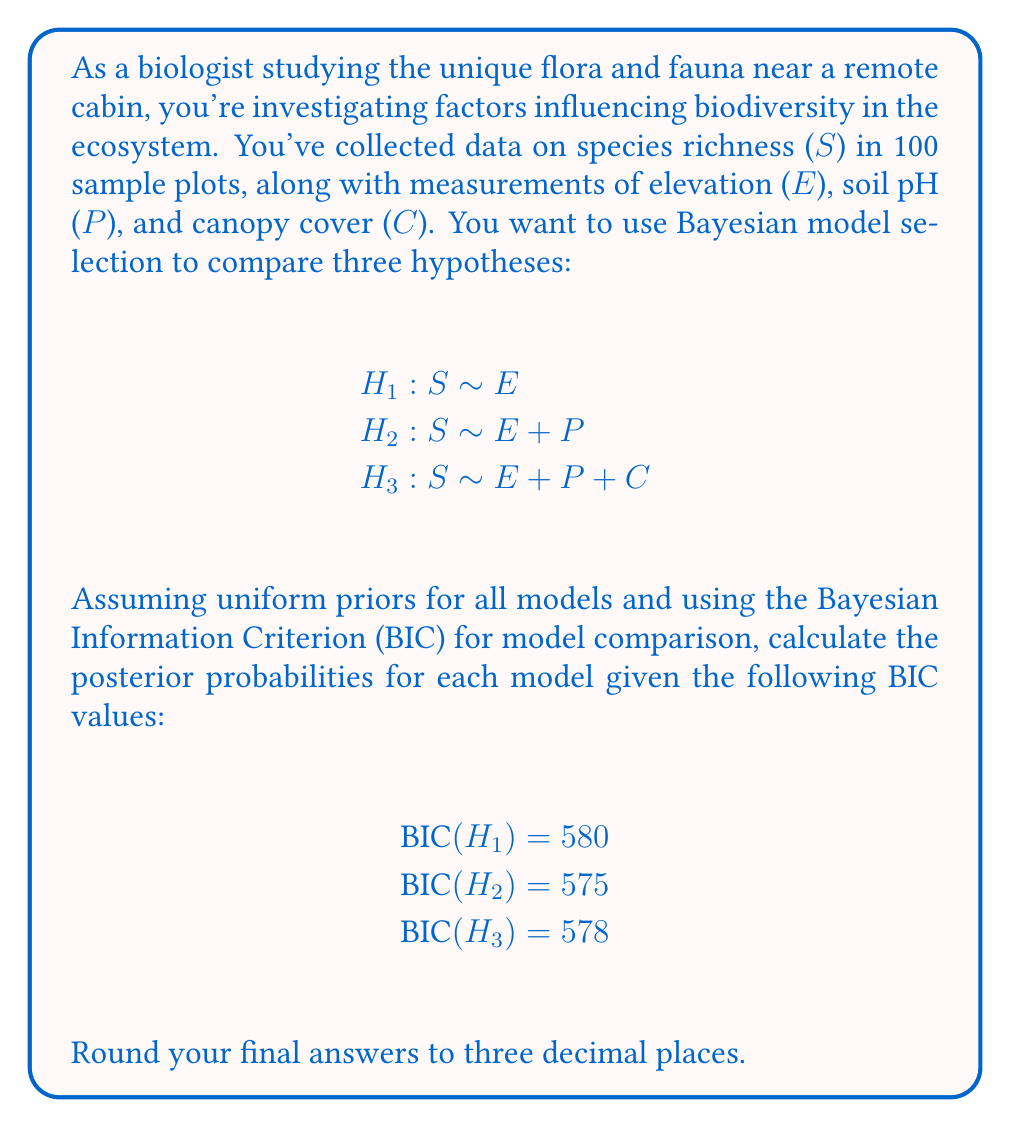Give your solution to this math problem. To compare these models using Bayesian model selection, we'll follow these steps:

1) First, recall that the Bayesian Information Criterion (BIC) is defined as:

   $$BIC = -2 \ln(\hat{L}) + k \ln(n)$$

   where $\hat{L}$ is the maximized likelihood, $k$ is the number of parameters, and $n$ is the sample size.

2) The BIC can be used to approximate the Bayes factor between two models. The Bayes factor for model i compared to model j is approximately:

   $$B_{ij} \approx \exp(-\frac{1}{2}(BIC_i - BIC_j))$$

3) Given uniform priors for all models, the posterior probability of each model is proportional to its marginal likelihood. We can use the BIC to approximate these probabilities:

   $$P(H_i|D) \approx \frac{\exp(-\frac{1}{2}BIC_i)}{\sum_j \exp(-\frac{1}{2}BIC_j)}$$

4) Let's calculate the denominator first:

   $$\sum_j \exp(-\frac{1}{2}BIC_j) = \exp(-\frac{1}{2}(580)) + \exp(-\frac{1}{2}(575)) + \exp(-\frac{1}{2}(578))$$
   $$= 1.357 \times 10^{-126} + 7.461 \times 10^{-126} + 2.752 \times 10^{-126}$$
   $$= 1.157 \times 10^{-125}$$

5) Now, we can calculate the posterior probability for each model:

   For H1: $$P(H_1|D) \approx \frac{1.357 \times 10^{-126}}{1.157 \times 10^{-125}} = 0.117$$

   For H2: $$P(H_2|D) \approx \frac{7.461 \times 10^{-126}}{1.157 \times 10^{-125}} = 0.645$$

   For H3: $$P(H_3|D) \approx \frac{2.752 \times 10^{-126}}{1.157 \times 10^{-125}} = 0.238$$

6) Rounding to three decimal places:

   P(H1|D) ≈ 0.117
   P(H2|D) ≈ 0.645
   P(H3|D) ≈ 0.238
Answer: P(H1|D) ≈ 0.117, P(H2|D) ≈ 0.645, P(H3|D) ≈ 0.238 